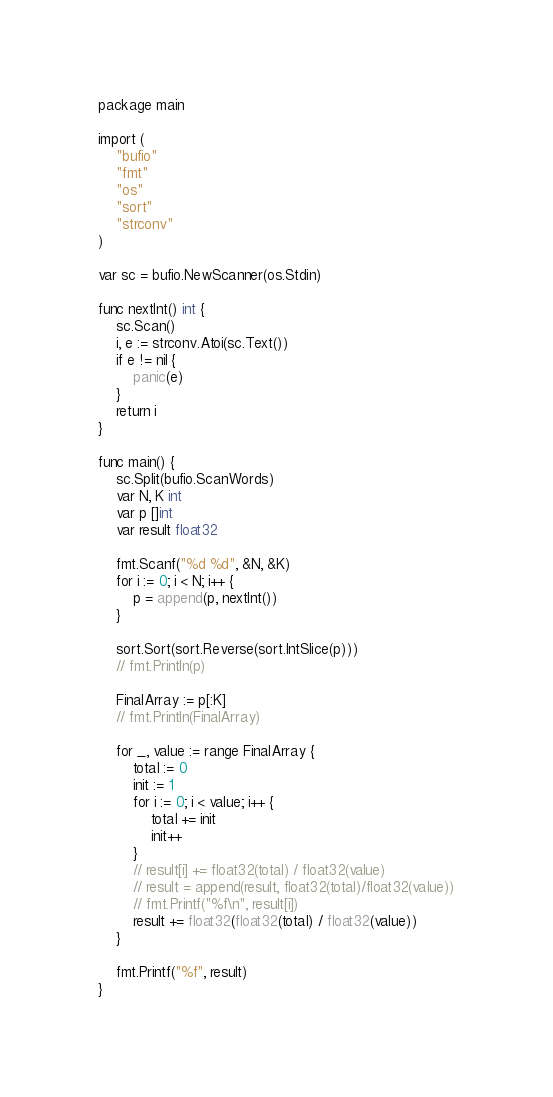<code> <loc_0><loc_0><loc_500><loc_500><_Go_>package main

import (
	"bufio"
	"fmt"
	"os"
	"sort"
	"strconv"
)

var sc = bufio.NewScanner(os.Stdin)

func nextInt() int {
	sc.Scan()
	i, e := strconv.Atoi(sc.Text())
	if e != nil {
		panic(e)
	}
	return i
}

func main() {
	sc.Split(bufio.ScanWords)
	var N, K int
	var p []int
	var result float32

	fmt.Scanf("%d %d", &N, &K)
	for i := 0; i < N; i++ {
		p = append(p, nextInt())
	}

	sort.Sort(sort.Reverse(sort.IntSlice(p)))
	// fmt.Println(p)

	FinalArray := p[:K]
	// fmt.Println(FinalArray)

	for _, value := range FinalArray {
		total := 0
		init := 1
		for i := 0; i < value; i++ {
			total += init
			init++
		}
		// result[i] += float32(total) / float32(value)
		// result = append(result, float32(total)/float32(value))
		// fmt.Printf("%f\n", result[i])
		result += float32(float32(total) / float32(value))
	}

	fmt.Printf("%f", result)
}
</code> 